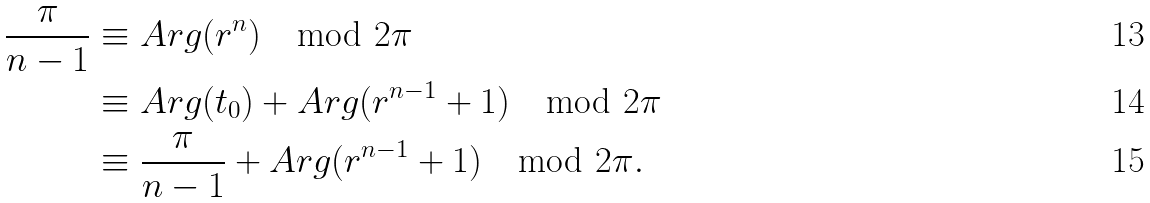<formula> <loc_0><loc_0><loc_500><loc_500>\frac { \pi } { n - 1 } & \equiv A r g ( r ^ { n } ) \mod 2 \pi \\ & \equiv A r g ( t _ { 0 } ) + A r g ( r ^ { n - 1 } + 1 ) \mod 2 \pi \\ & \equiv \frac { \pi } { n - 1 } + A r g ( r ^ { n - 1 } + 1 ) \mod 2 \pi .</formula> 